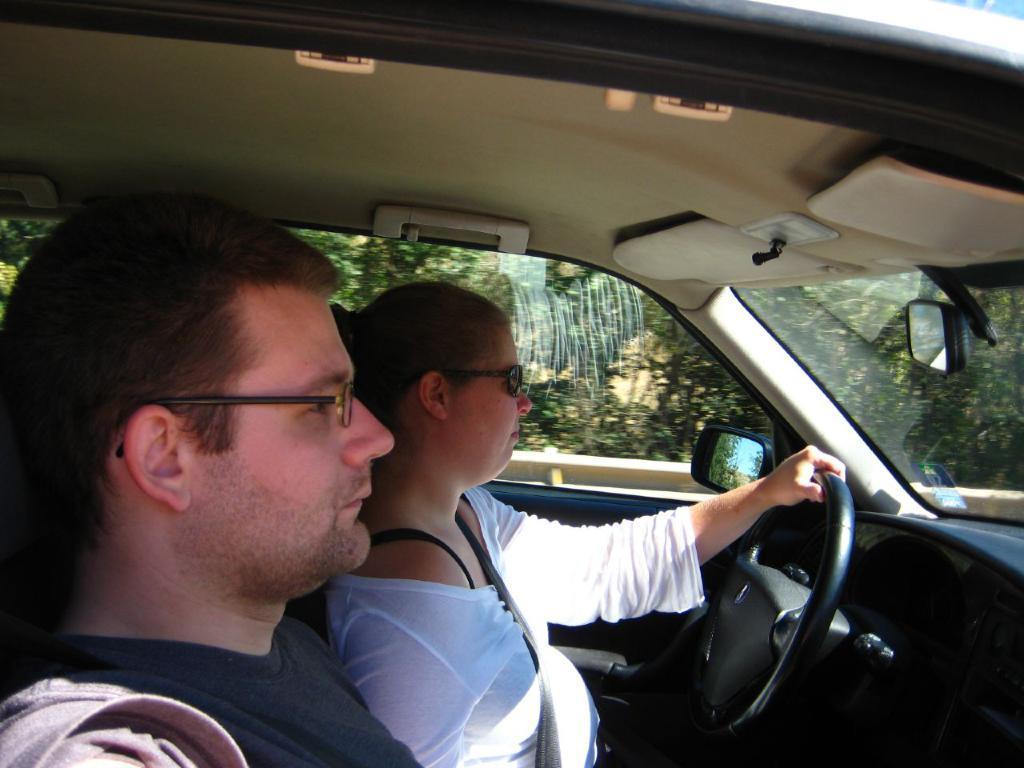How would you summarize this image in a sentence or two? In this picture we can see women wore goggle holding steering with her hand and beside to her man and they are inside the car and from window of car we can see trees. 